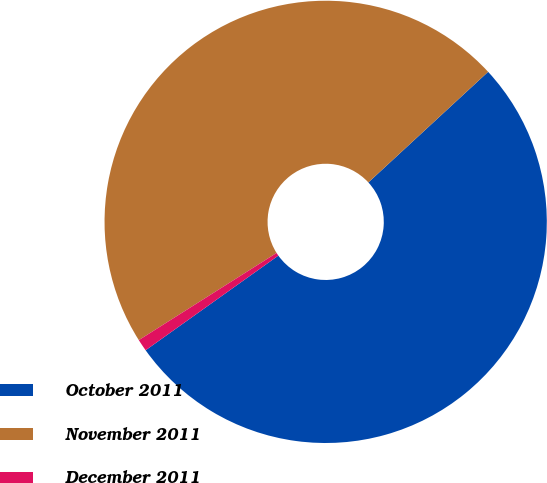Convert chart. <chart><loc_0><loc_0><loc_500><loc_500><pie_chart><fcel>October 2011<fcel>November 2011<fcel>December 2011<nl><fcel>52.01%<fcel>47.11%<fcel>0.88%<nl></chart> 